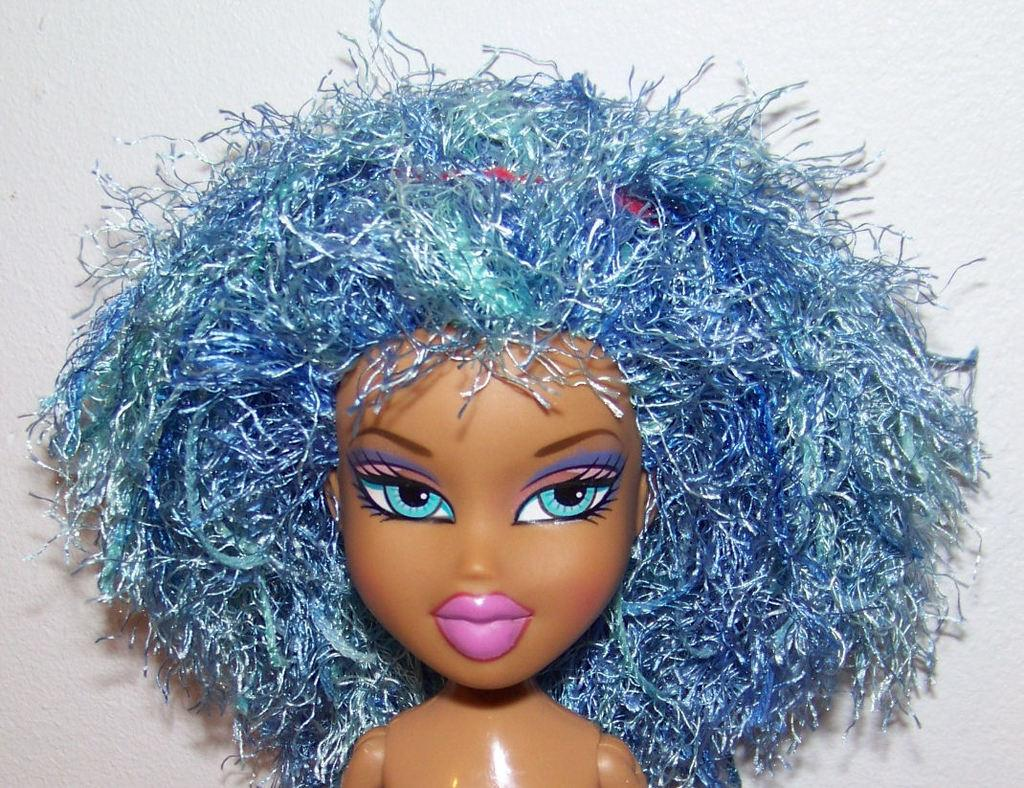What is the main subject of the image? There is a doll in the image. What color is the background of the image? The background of the image is white. What class does the doll's sister attend in the image? There is no information about a class or a sister in the image, as it only features a doll and a white background. 